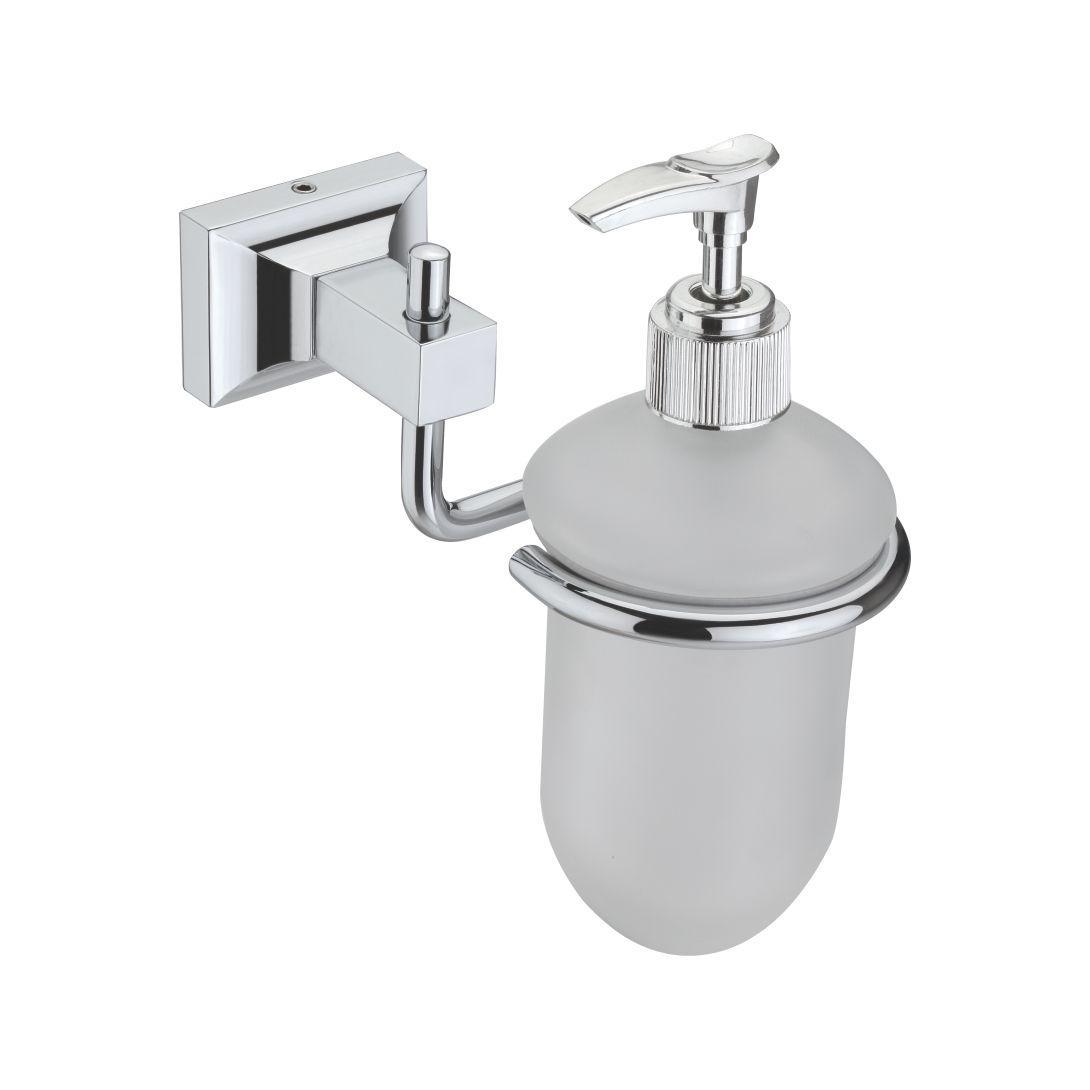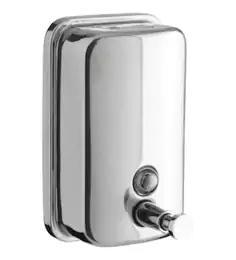The first image is the image on the left, the second image is the image on the right. For the images displayed, is the sentence "One dispenser is cylinder shaped with a pump at the top." factually correct? Answer yes or no. Yes. 